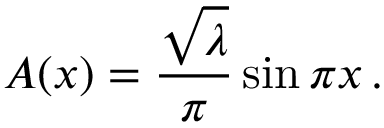<formula> <loc_0><loc_0><loc_500><loc_500>A ( x ) = { \frac { \sqrt { \lambda } } { \pi } } \sin \pi x \, .</formula> 